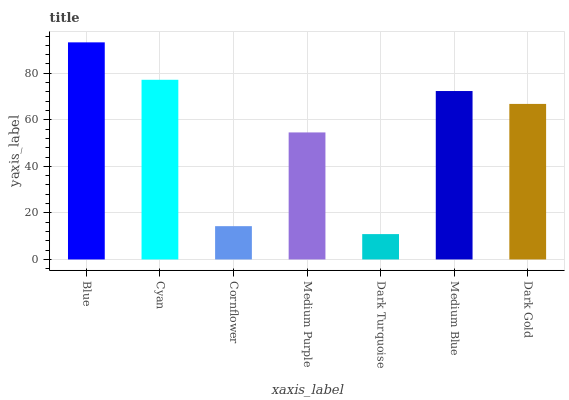Is Dark Turquoise the minimum?
Answer yes or no. Yes. Is Blue the maximum?
Answer yes or no. Yes. Is Cyan the minimum?
Answer yes or no. No. Is Cyan the maximum?
Answer yes or no. No. Is Blue greater than Cyan?
Answer yes or no. Yes. Is Cyan less than Blue?
Answer yes or no. Yes. Is Cyan greater than Blue?
Answer yes or no. No. Is Blue less than Cyan?
Answer yes or no. No. Is Dark Gold the high median?
Answer yes or no. Yes. Is Dark Gold the low median?
Answer yes or no. Yes. Is Cornflower the high median?
Answer yes or no. No. Is Medium Purple the low median?
Answer yes or no. No. 